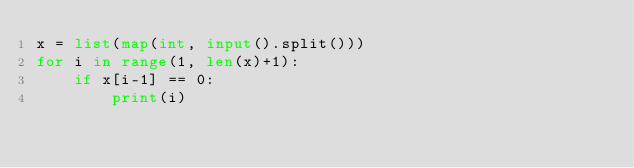Convert code to text. <code><loc_0><loc_0><loc_500><loc_500><_Python_>x = list(map(int, input().split()))
for i in range(1, len(x)+1):
    if x[i-1] == 0:
        print(i)</code> 